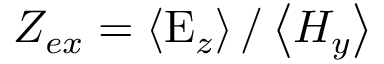<formula> <loc_0><loc_0><loc_500><loc_500>Z _ { e x } = \left \langle E _ { z } \right \rangle / \left \langle H _ { y } \right \rangle</formula> 